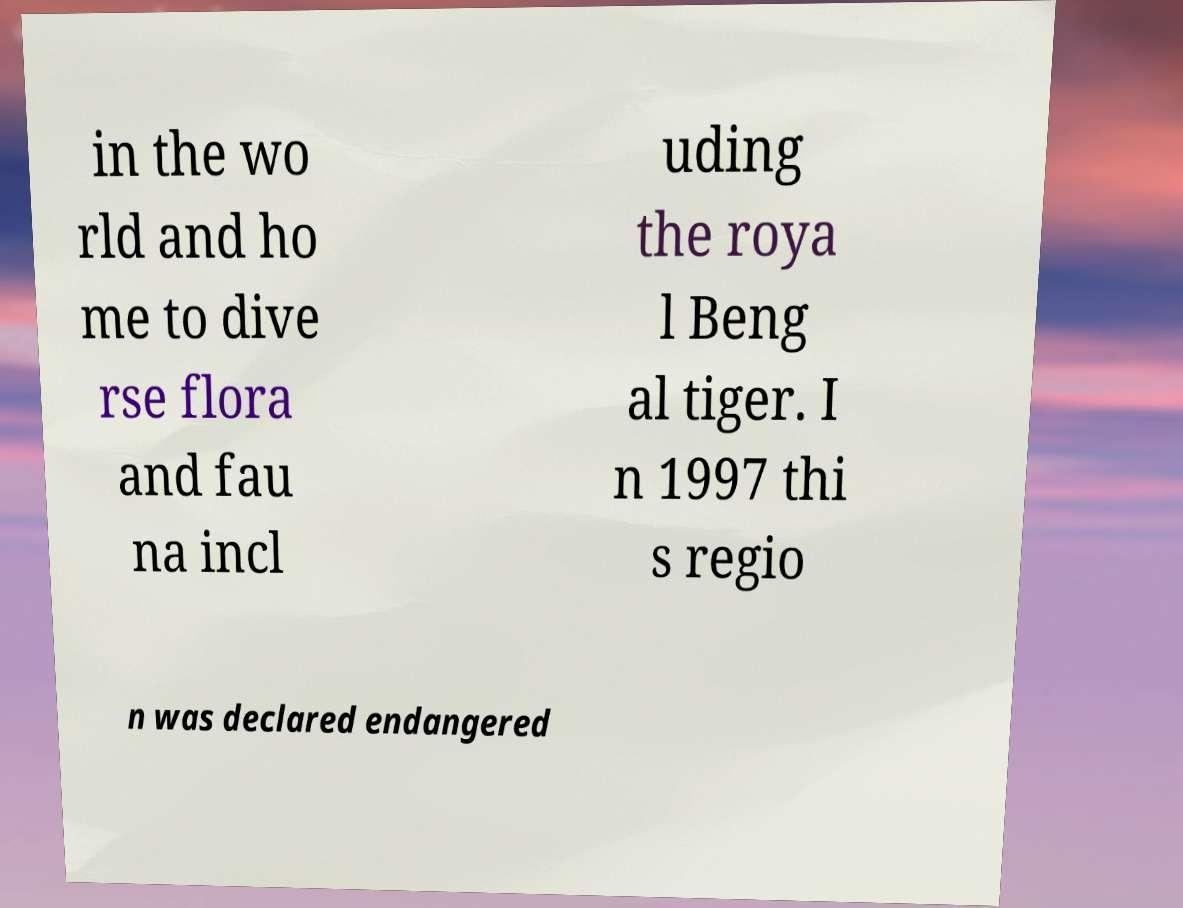What messages or text are displayed in this image? I need them in a readable, typed format. in the wo rld and ho me to dive rse flora and fau na incl uding the roya l Beng al tiger. I n 1997 thi s regio n was declared endangered 